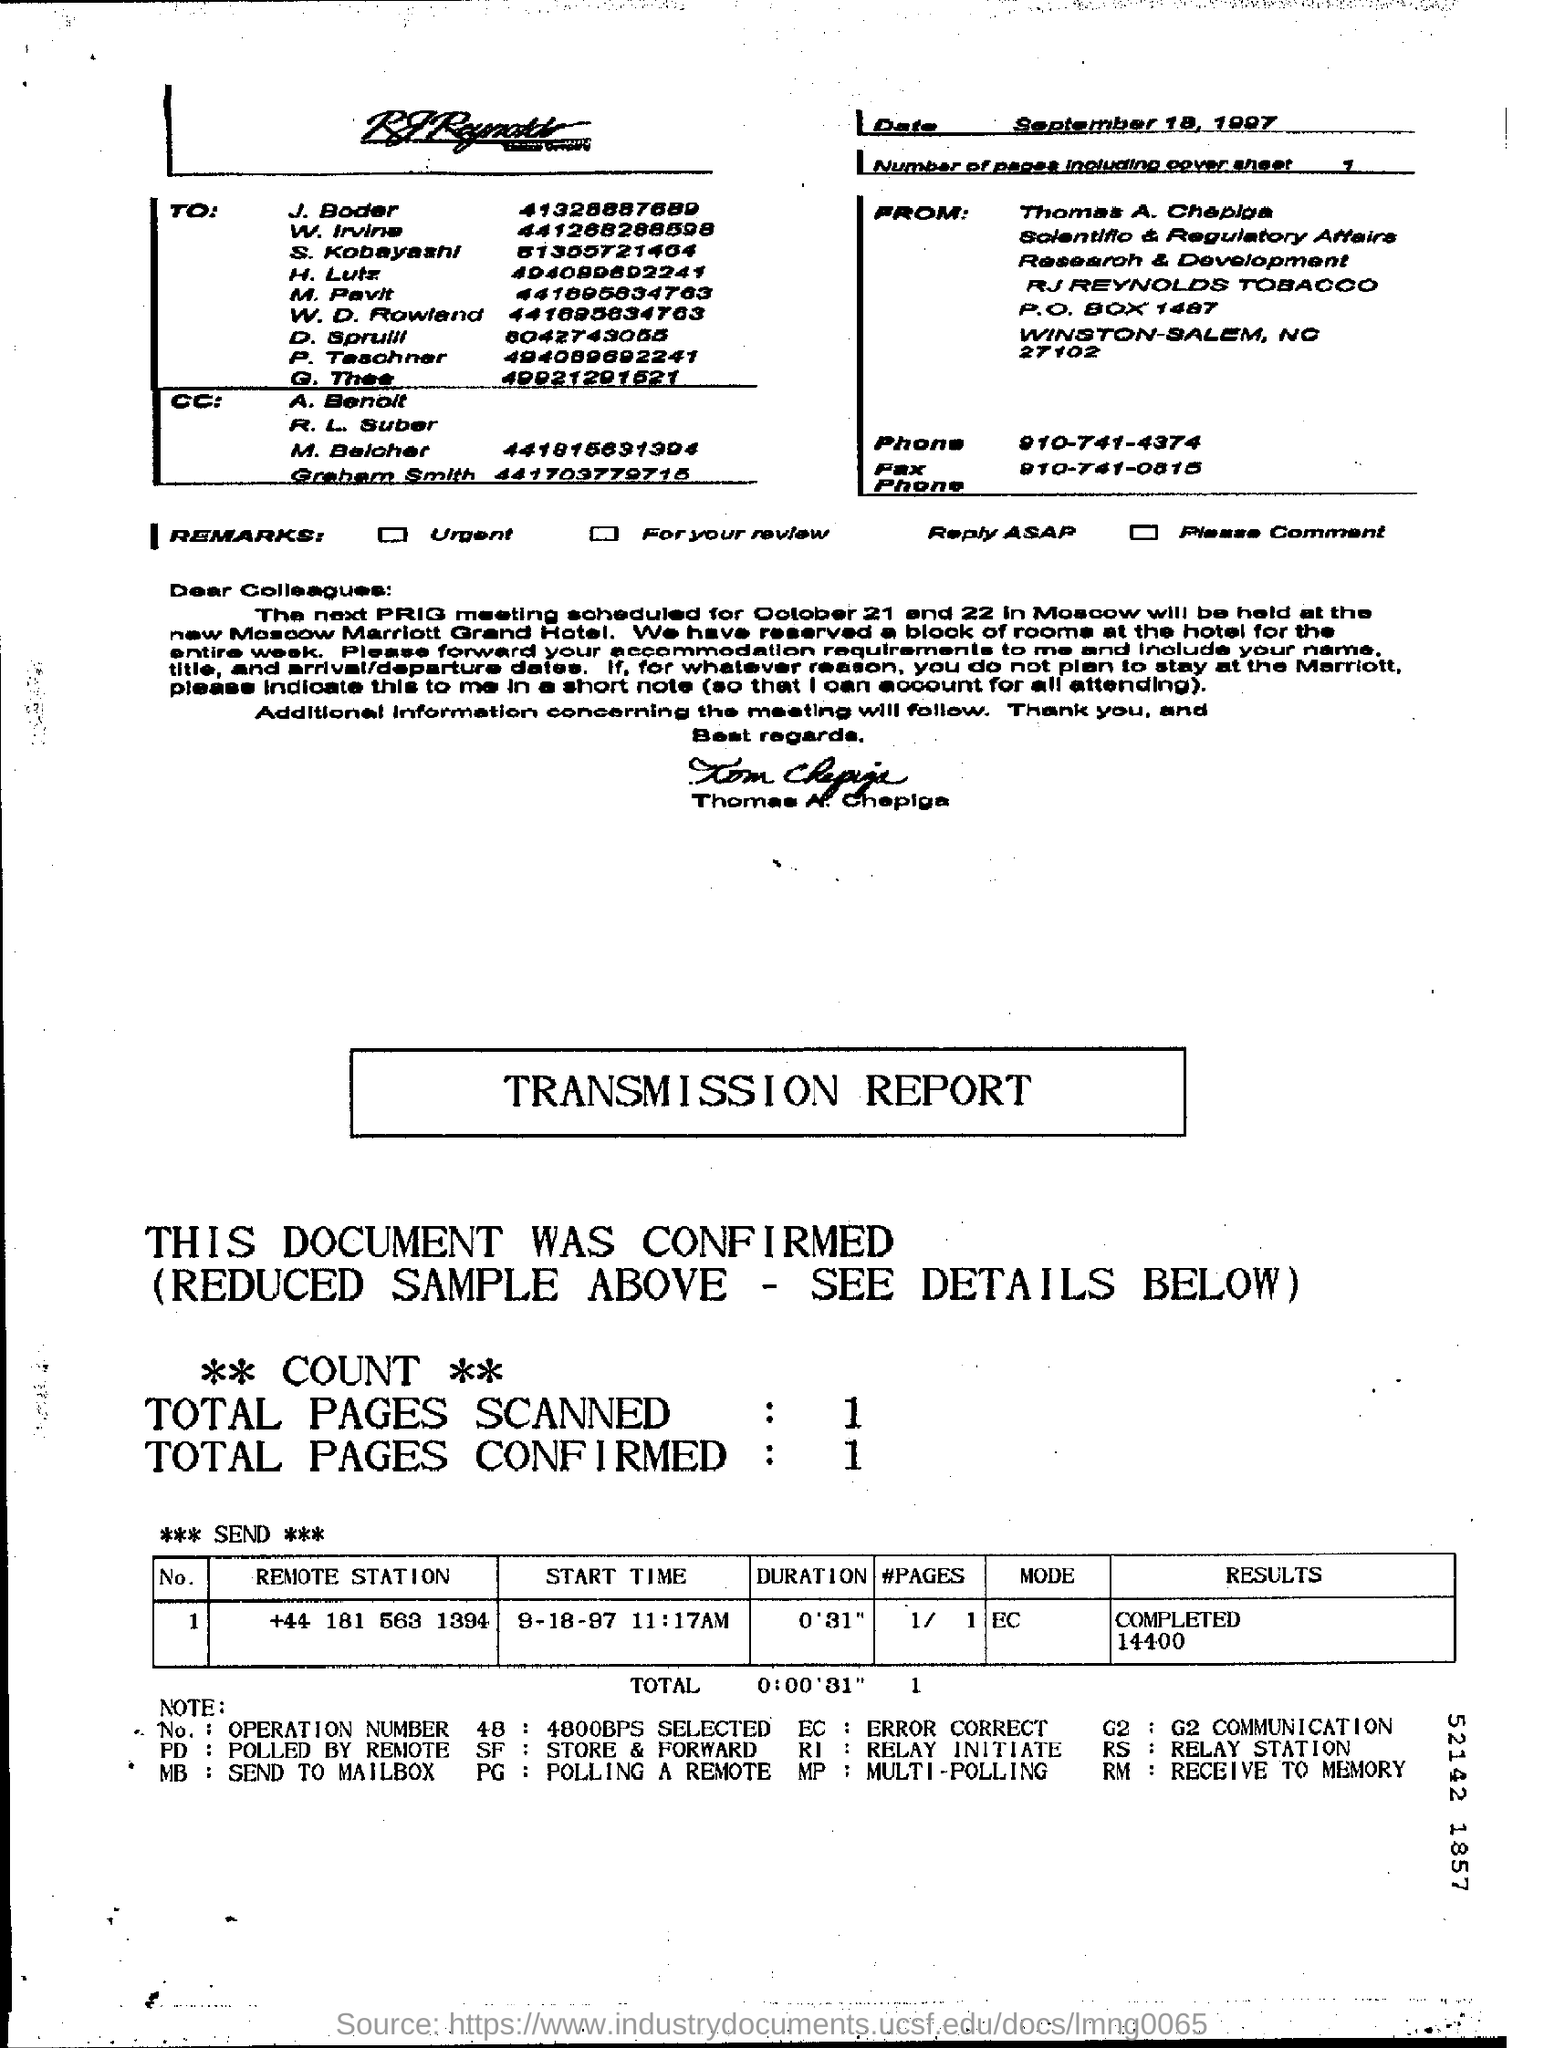Point out several critical features in this image. The number of pages, including the cover sheet, is 1.. The date is September 18, 1997. The result for the remote station with the telephone number +44 181 563 1394 is 14400. The next PRIG meeting is scheduled for October 21 and 22. The total number of pages confirmed is 1.. 